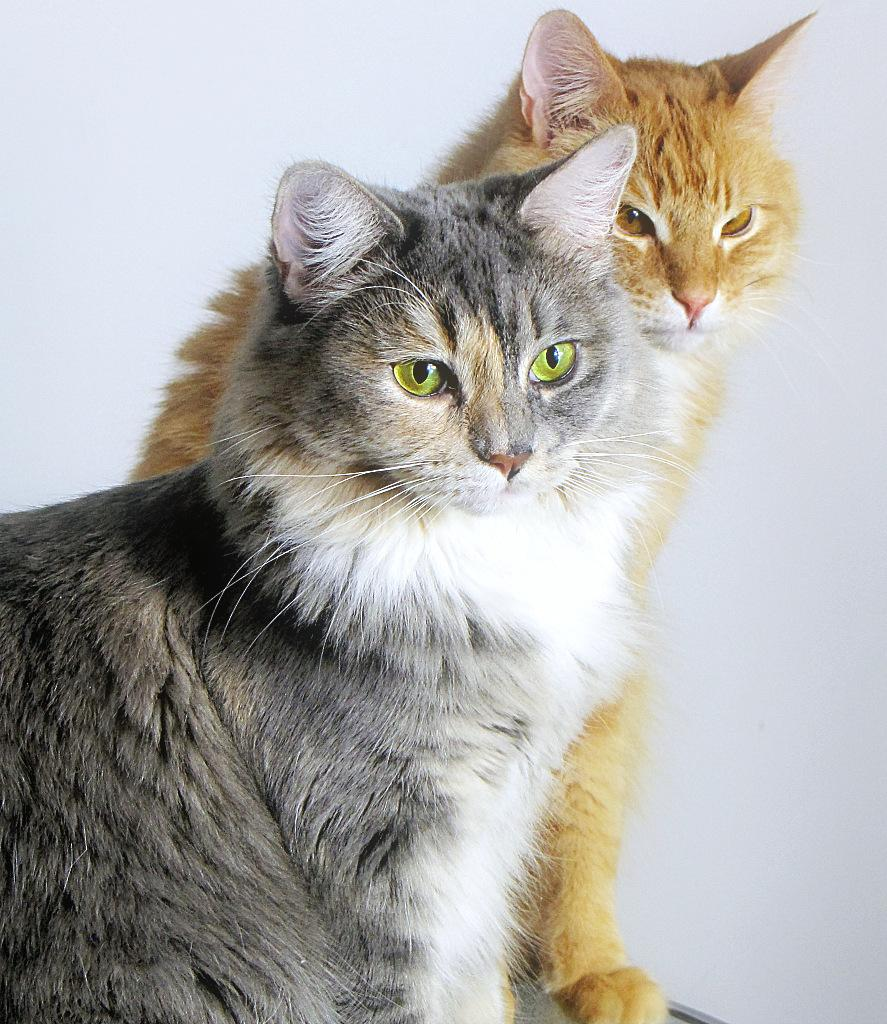How many cats are present in the image? There are two cats in the image. What colors can be seen on the cats? The cats have brown, white, and grey colors. What is the color of the background in the image? The background of the image is white. Can you see any cabbage growing in the image? There is no cabbage present in the image; it features two cats with brown, white, and grey colors against a white background. Is it summer in the image? The image does not provide any information about the season, so it cannot be determined if it is summer or not. 